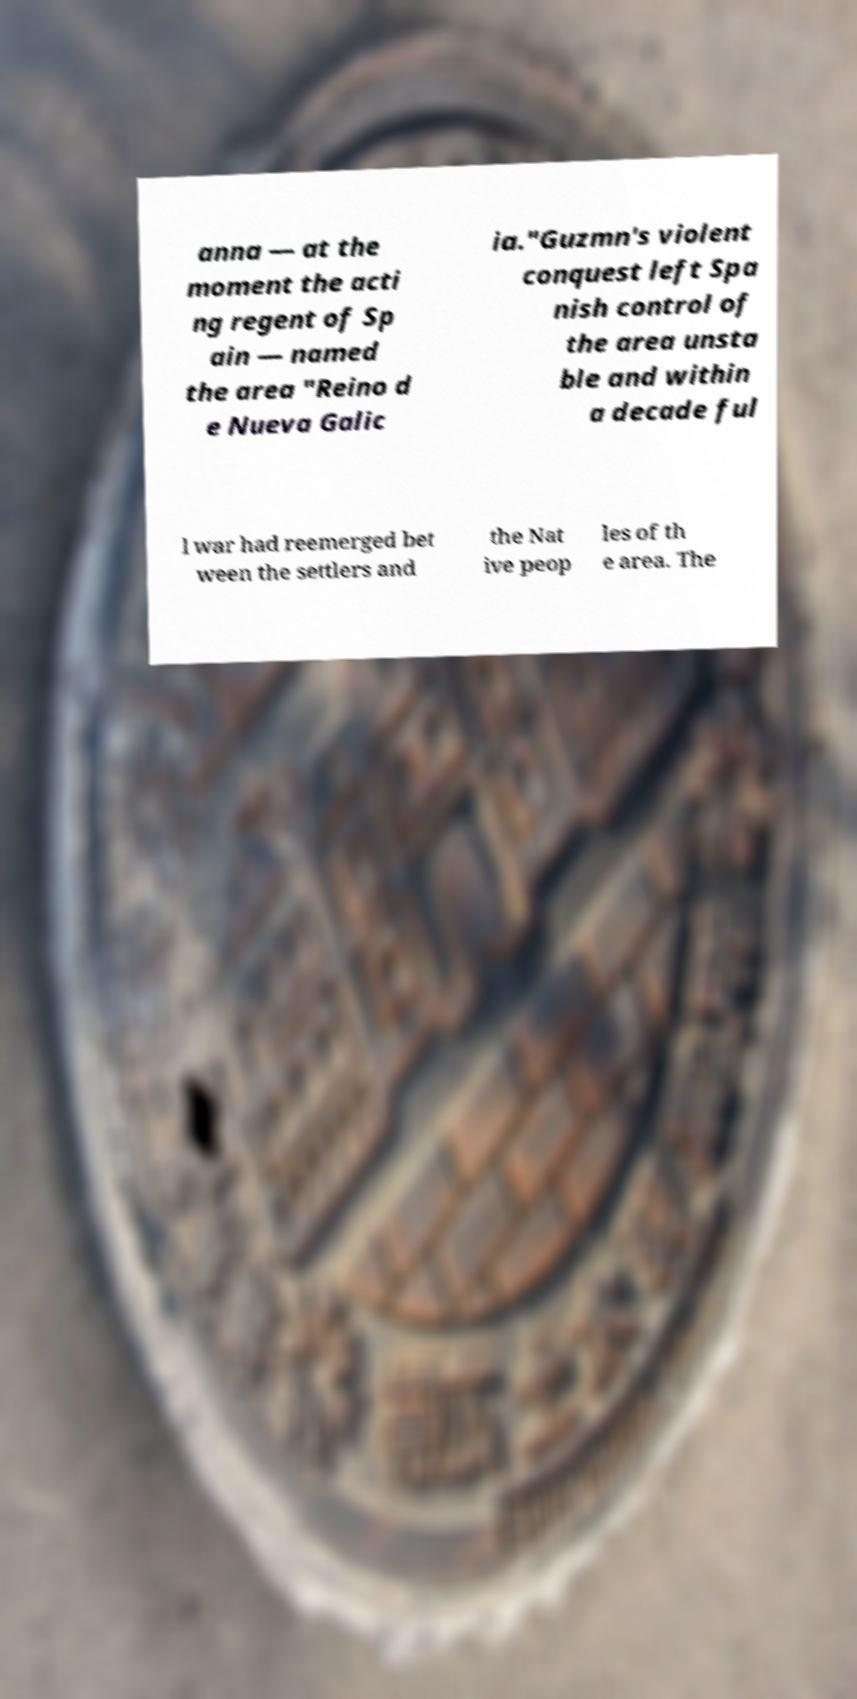For documentation purposes, I need the text within this image transcribed. Could you provide that? anna — at the moment the acti ng regent of Sp ain — named the area "Reino d e Nueva Galic ia."Guzmn's violent conquest left Spa nish control of the area unsta ble and within a decade ful l war had reemerged bet ween the settlers and the Nat ive peop les of th e area. The 